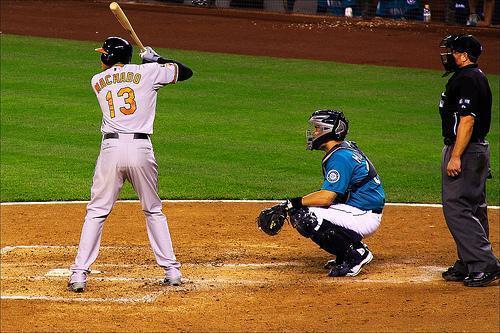How many baseball players are in this photo?
Give a very brief answer. 3. How many baseball bats are visible?
Give a very brief answer. 1. 